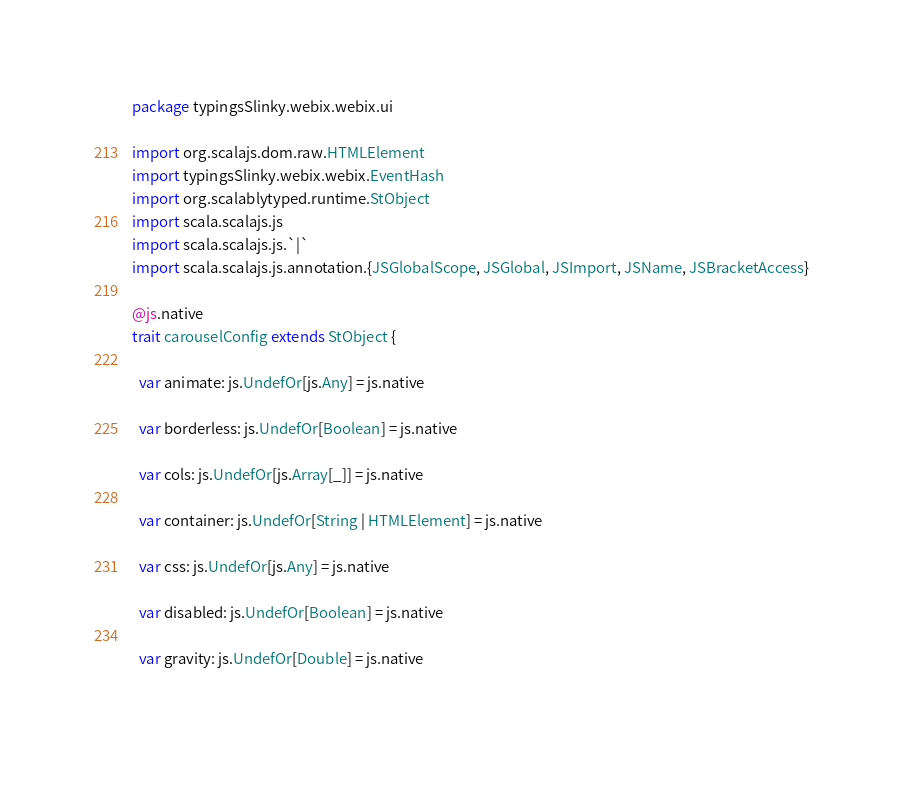Convert code to text. <code><loc_0><loc_0><loc_500><loc_500><_Scala_>package typingsSlinky.webix.webix.ui

import org.scalajs.dom.raw.HTMLElement
import typingsSlinky.webix.webix.EventHash
import org.scalablytyped.runtime.StObject
import scala.scalajs.js
import scala.scalajs.js.`|`
import scala.scalajs.js.annotation.{JSGlobalScope, JSGlobal, JSImport, JSName, JSBracketAccess}

@js.native
trait carouselConfig extends StObject {
  
  var animate: js.UndefOr[js.Any] = js.native
  
  var borderless: js.UndefOr[Boolean] = js.native
  
  var cols: js.UndefOr[js.Array[_]] = js.native
  
  var container: js.UndefOr[String | HTMLElement] = js.native
  
  var css: js.UndefOr[js.Any] = js.native
  
  var disabled: js.UndefOr[Boolean] = js.native
  
  var gravity: js.UndefOr[Double] = js.native
  </code> 